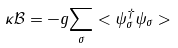<formula> <loc_0><loc_0><loc_500><loc_500>\kappa \mathcal { B } = - g \underset { \sigma } { \sum } < \psi ^ { \dagger } _ { \sigma } \psi _ { \sigma } ></formula> 